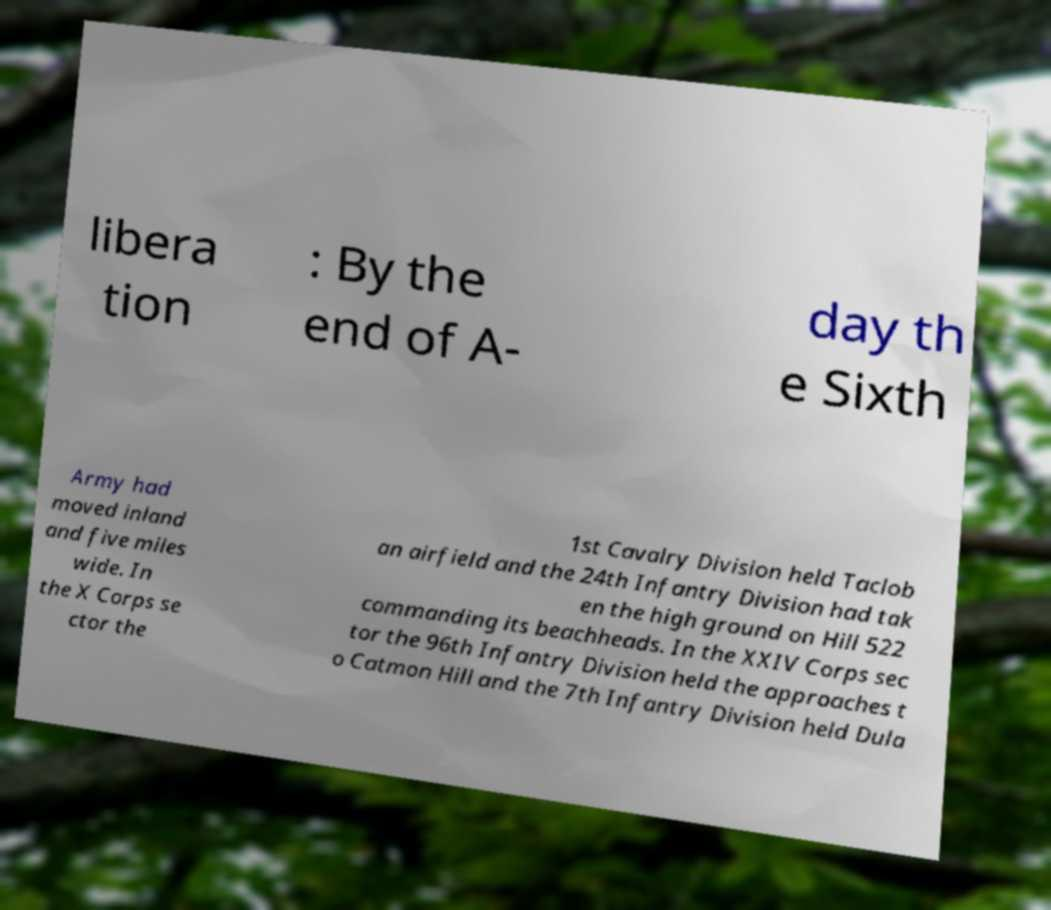There's text embedded in this image that I need extracted. Can you transcribe it verbatim? libera tion : By the end of A- day th e Sixth Army had moved inland and five miles wide. In the X Corps se ctor the 1st Cavalry Division held Taclob an airfield and the 24th Infantry Division had tak en the high ground on Hill 522 commanding its beachheads. In the XXIV Corps sec tor the 96th Infantry Division held the approaches t o Catmon Hill and the 7th Infantry Division held Dula 